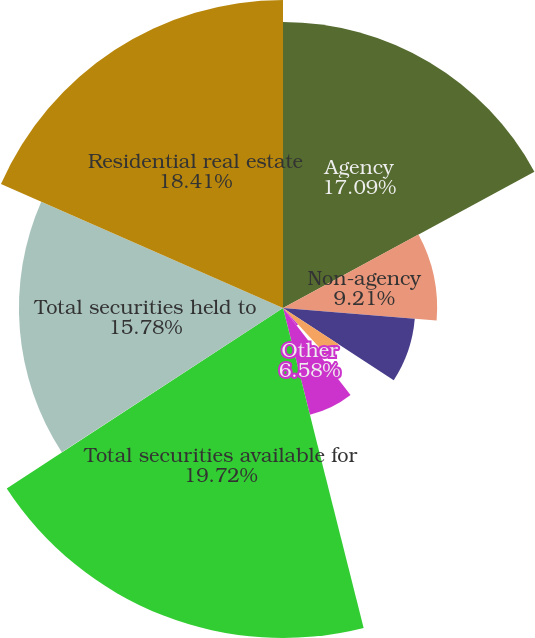Convert chart. <chart><loc_0><loc_0><loc_500><loc_500><pie_chart><fcel>Agency<fcel>Non-agency<fcel>Commercial mortgage-backed<fcel>Asset-backed<fcel>US Treasury and government<fcel>Other<fcel>Total securities available for<fcel>Asset-backed US Treasury and<fcel>Total securities held to<fcel>Residential real estate<nl><fcel>17.09%<fcel>9.21%<fcel>7.9%<fcel>3.96%<fcel>1.33%<fcel>6.58%<fcel>19.72%<fcel>0.02%<fcel>15.78%<fcel>18.41%<nl></chart> 